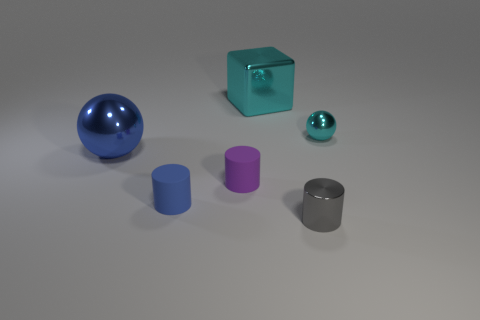Is there a large purple cylinder that has the same material as the small blue cylinder?
Provide a succinct answer. No. What size is the blue object that is the same shape as the tiny gray thing?
Provide a short and direct response. Small. Is the number of large cyan blocks that are behind the tiny cyan thing the same as the number of large cyan cubes?
Your answer should be compact. Yes. Do the metal object to the right of the tiny gray metallic cylinder and the purple object have the same shape?
Your response must be concise. No. There is a tiny cyan shiny object; what shape is it?
Your answer should be very brief. Sphere. There is a tiny cylinder that is to the right of the cyan metal thing to the left of the cyan shiny thing on the right side of the big metal block; what is it made of?
Your answer should be very brief. Metal. There is a big thing that is the same color as the tiny metal ball; what is it made of?
Your answer should be compact. Metal. What number of objects are tiny gray shiny cylinders or small matte cylinders?
Offer a terse response. 3. Is the material of the small purple object that is to the left of the big cyan metal block the same as the big cyan cube?
Make the answer very short. No. How many objects are either metal balls that are left of the gray metal thing or large blue metallic balls?
Your response must be concise. 1. 